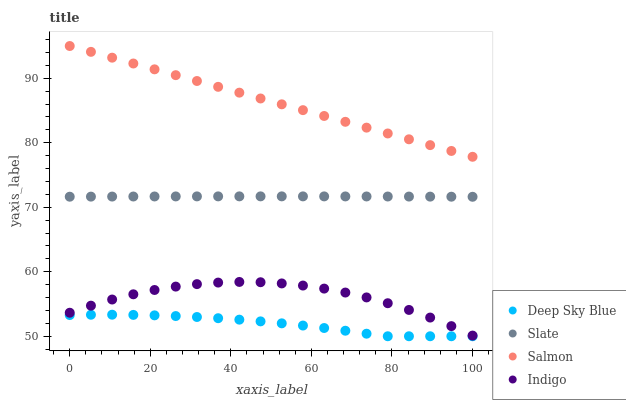Does Deep Sky Blue have the minimum area under the curve?
Answer yes or no. Yes. Does Salmon have the maximum area under the curve?
Answer yes or no. Yes. Does Slate have the minimum area under the curve?
Answer yes or no. No. Does Slate have the maximum area under the curve?
Answer yes or no. No. Is Salmon the smoothest?
Answer yes or no. Yes. Is Indigo the roughest?
Answer yes or no. Yes. Is Slate the smoothest?
Answer yes or no. No. Is Slate the roughest?
Answer yes or no. No. Does Deep Sky Blue have the lowest value?
Answer yes or no. Yes. Does Slate have the lowest value?
Answer yes or no. No. Does Salmon have the highest value?
Answer yes or no. Yes. Does Slate have the highest value?
Answer yes or no. No. Is Slate less than Salmon?
Answer yes or no. Yes. Is Salmon greater than Slate?
Answer yes or no. Yes. Does Slate intersect Salmon?
Answer yes or no. No. 